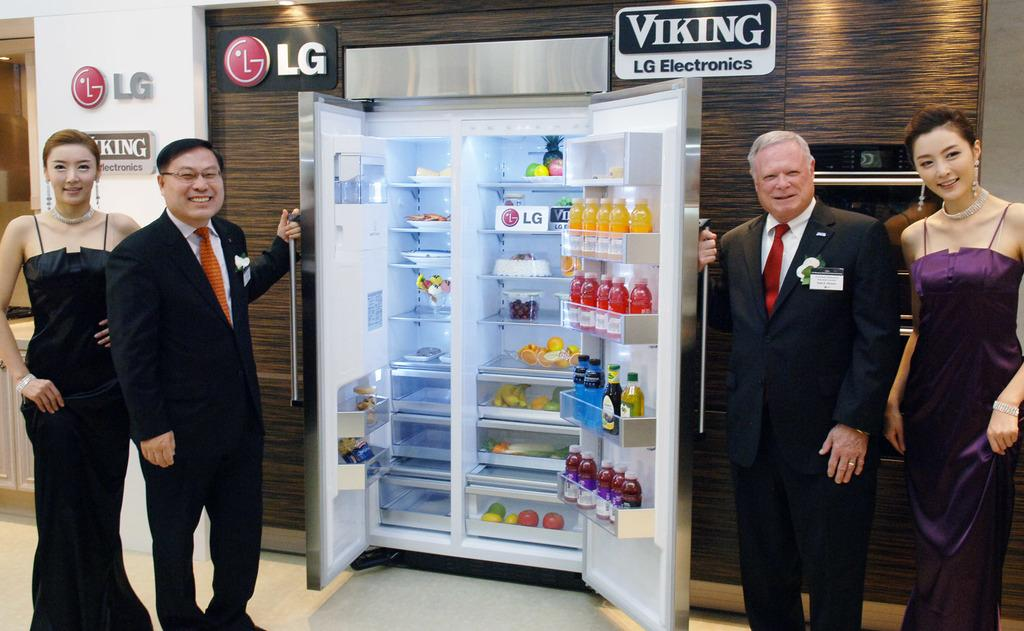<image>
Relay a brief, clear account of the picture shown. Several people pose with a refrigerator in an LG Electronics show room. 